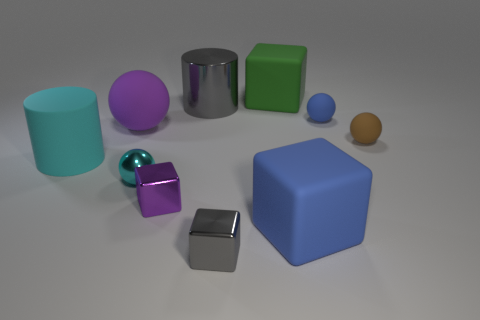What is the size of the metal block that is behind the rubber block in front of the tiny purple thing?
Offer a very short reply. Small. There is another large object that is the same shape as the large cyan thing; what color is it?
Provide a succinct answer. Gray. How many large matte balls have the same color as the metallic cylinder?
Offer a very short reply. 0. Do the blue matte cube and the purple matte ball have the same size?
Your answer should be compact. Yes. What is the material of the small gray object?
Provide a short and direct response. Metal. There is a block that is the same material as the small gray thing; what color is it?
Offer a very short reply. Purple. Do the brown object and the purple object that is to the left of the purple shiny object have the same material?
Give a very brief answer. Yes. What number of big cyan cylinders are made of the same material as the tiny cyan ball?
Provide a succinct answer. 0. There is a blue object behind the tiny purple metallic block; what shape is it?
Provide a short and direct response. Sphere. Is the material of the cylinder to the right of the purple rubber ball the same as the tiny thing that is in front of the large blue rubber thing?
Make the answer very short. Yes. 